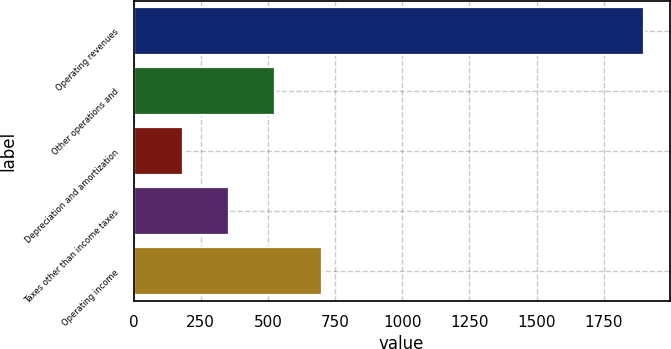<chart> <loc_0><loc_0><loc_500><loc_500><bar_chart><fcel>Operating revenues<fcel>Other operations and<fcel>Depreciation and amortization<fcel>Taxes other than income taxes<fcel>Operating income<nl><fcel>1901<fcel>528.2<fcel>185<fcel>356.6<fcel>699.8<nl></chart> 